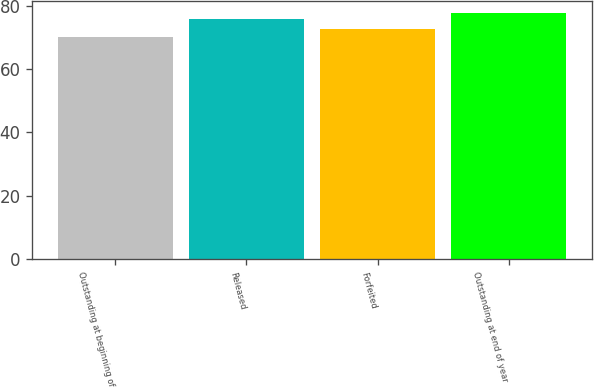Convert chart to OTSL. <chart><loc_0><loc_0><loc_500><loc_500><bar_chart><fcel>Outstanding at beginning of<fcel>Released<fcel>Forfeited<fcel>Outstanding at end of year<nl><fcel>70.19<fcel>75.9<fcel>72.81<fcel>77.7<nl></chart> 